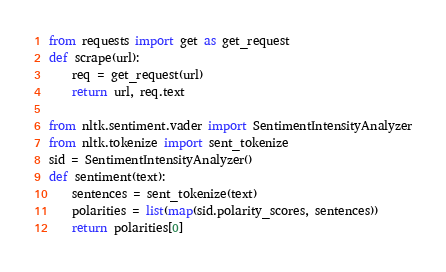<code> <loc_0><loc_0><loc_500><loc_500><_Python_>from requests import get as get_request
def scrape(url):
    req = get_request(url)
    return url, req.text

from nltk.sentiment.vader import SentimentIntensityAnalyzer
from nltk.tokenize import sent_tokenize
sid = SentimentIntensityAnalyzer()
def sentiment(text):
    sentences = sent_tokenize(text)
    polarities = list(map(sid.polarity_scores, sentences))
    return polarities[0]</code> 